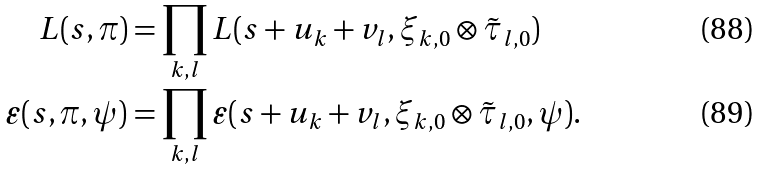Convert formula to latex. <formula><loc_0><loc_0><loc_500><loc_500>L ( s , \pi ) & = \prod _ { k , l } L ( s + u _ { k } + v _ { l } , \xi _ { k , 0 } \otimes \tilde { \tau } _ { l , 0 } ) \\ \varepsilon ( s , \pi , \psi ) & = \prod _ { k , l } \varepsilon ( s + u _ { k } + v _ { l } , \xi _ { k , 0 } \otimes \tilde { \tau } _ { l , 0 } , \psi ) .</formula> 